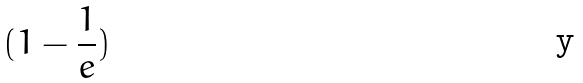<formula> <loc_0><loc_0><loc_500><loc_500>( 1 - \frac { 1 } { e } )</formula> 